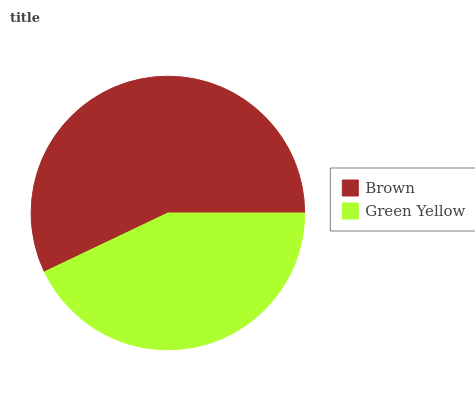Is Green Yellow the minimum?
Answer yes or no. Yes. Is Brown the maximum?
Answer yes or no. Yes. Is Green Yellow the maximum?
Answer yes or no. No. Is Brown greater than Green Yellow?
Answer yes or no. Yes. Is Green Yellow less than Brown?
Answer yes or no. Yes. Is Green Yellow greater than Brown?
Answer yes or no. No. Is Brown less than Green Yellow?
Answer yes or no. No. Is Brown the high median?
Answer yes or no. Yes. Is Green Yellow the low median?
Answer yes or no. Yes. Is Green Yellow the high median?
Answer yes or no. No. Is Brown the low median?
Answer yes or no. No. 